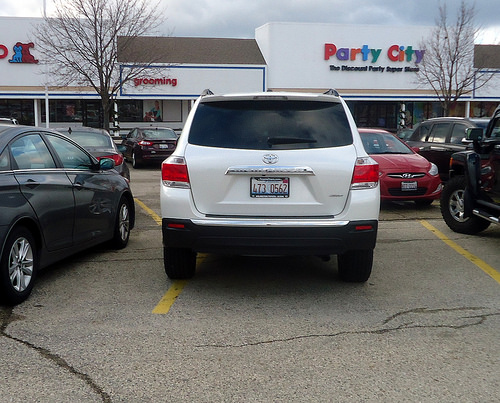<image>
Is there a car in front of the pet co? Yes. The car is positioned in front of the pet co, appearing closer to the camera viewpoint. Is the street in front of the car? No. The street is not in front of the car. The spatial positioning shows a different relationship between these objects. 